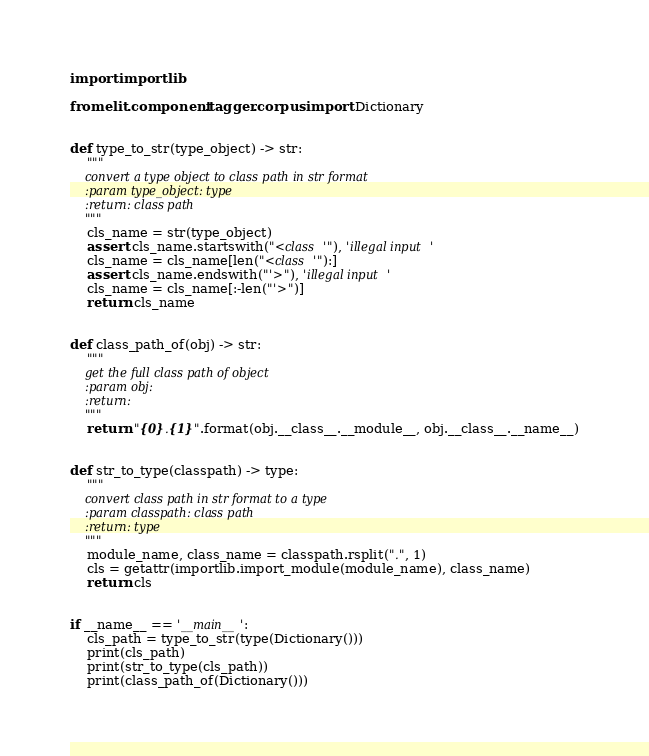Convert code to text. <code><loc_0><loc_0><loc_500><loc_500><_Python_>import importlib

from elit.component.tagger.corpus import Dictionary


def type_to_str(type_object) -> str:
    """
    convert a type object to class path in str format
    :param type_object: type
    :return: class path
    """
    cls_name = str(type_object)
    assert cls_name.startswith("<class '"), 'illegal input'
    cls_name = cls_name[len("<class '"):]
    assert cls_name.endswith("'>"), 'illegal input'
    cls_name = cls_name[:-len("'>")]
    return cls_name


def class_path_of(obj) -> str:
    """
    get the full class path of object
    :param obj:
    :return:
    """
    return "{0}.{1}".format(obj.__class__.__module__, obj.__class__.__name__)


def str_to_type(classpath) -> type:
    """
    convert class path in str format to a type
    :param classpath: class path
    :return: type
    """
    module_name, class_name = classpath.rsplit(".", 1)
    cls = getattr(importlib.import_module(module_name), class_name)
    return cls


if __name__ == '__main__':
    cls_path = type_to_str(type(Dictionary()))
    print(cls_path)
    print(str_to_type(cls_path))
    print(class_path_of(Dictionary()))
</code> 